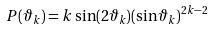<formula> <loc_0><loc_0><loc_500><loc_500>P ( \vartheta _ { k } ) = k \sin ( 2 \vartheta _ { k } ) ( \sin \vartheta _ { k } ) ^ { 2 k - 2 }</formula> 